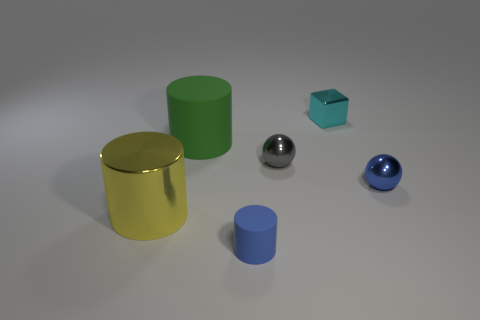Subtract all tiny matte cylinders. How many cylinders are left? 2 Add 2 small gray balls. How many objects exist? 8 Subtract all blue cylinders. How many cylinders are left? 2 Subtract 1 spheres. How many spheres are left? 1 Subtract all balls. How many objects are left? 4 Add 3 green cylinders. How many green cylinders are left? 4 Add 2 blue matte spheres. How many blue matte spheres exist? 2 Subtract 1 gray balls. How many objects are left? 5 Subtract all purple balls. Subtract all red blocks. How many balls are left? 2 Subtract all green rubber cubes. Subtract all tiny shiny blocks. How many objects are left? 5 